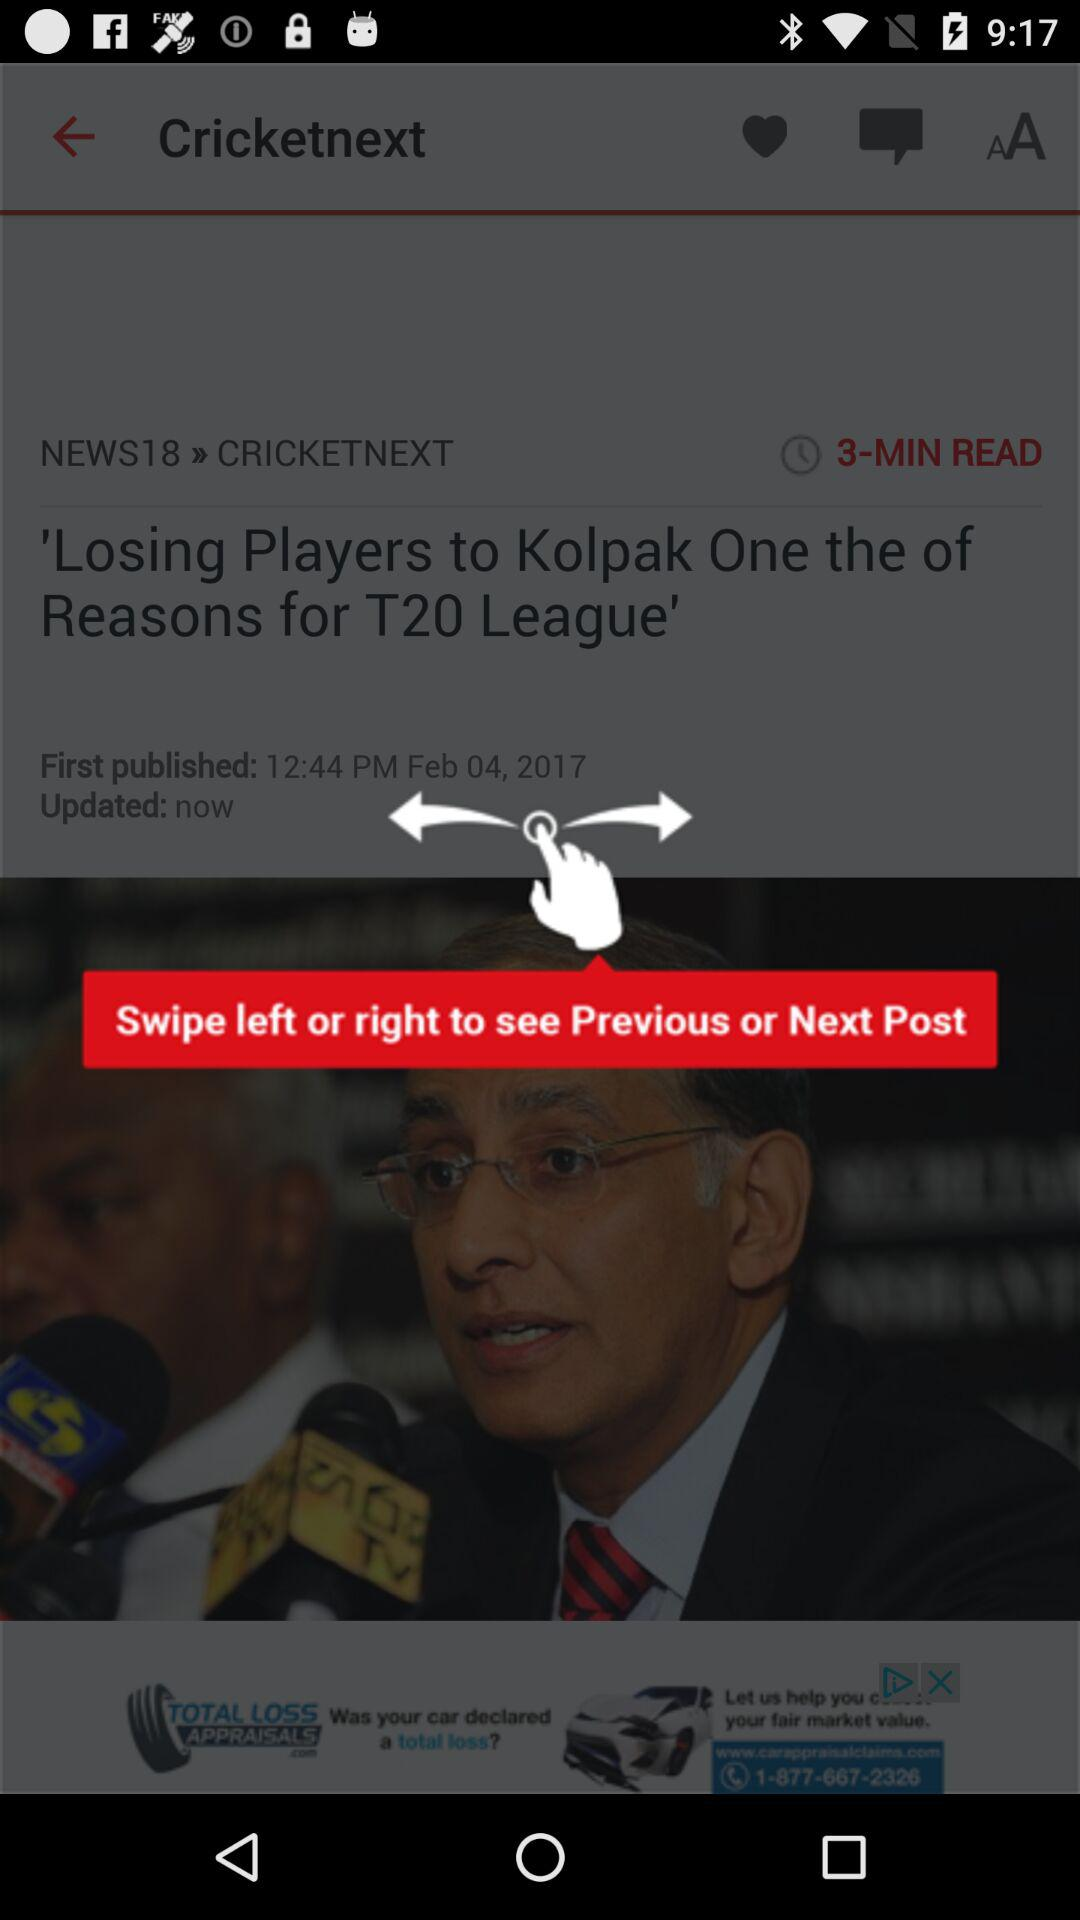What is the headline of the article? The headline of the article is "'Losing Players to Kolpak One the of Reasons for T20 League'". 